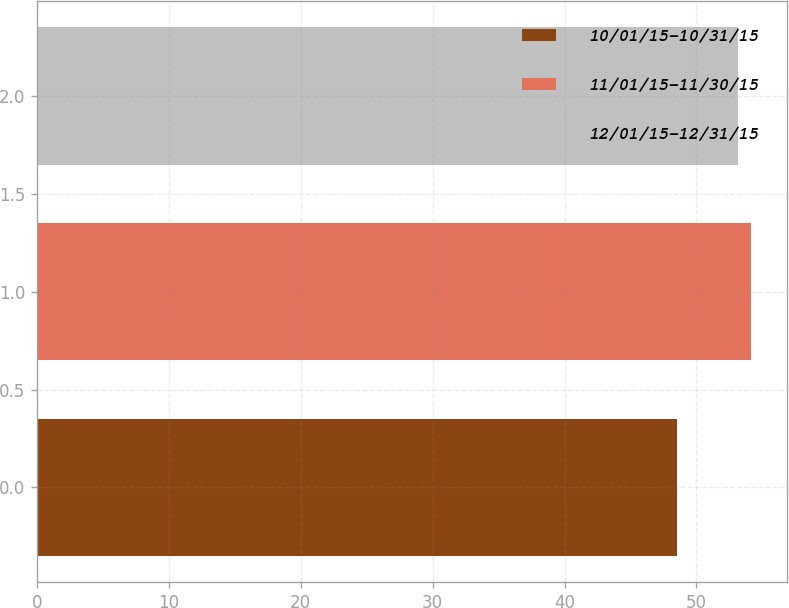Convert chart. <chart><loc_0><loc_0><loc_500><loc_500><bar_chart><fcel>10/01/15-10/31/15<fcel>11/01/15-11/30/15<fcel>12/01/15-12/31/15<nl><fcel>48.52<fcel>54.17<fcel>53.16<nl></chart> 